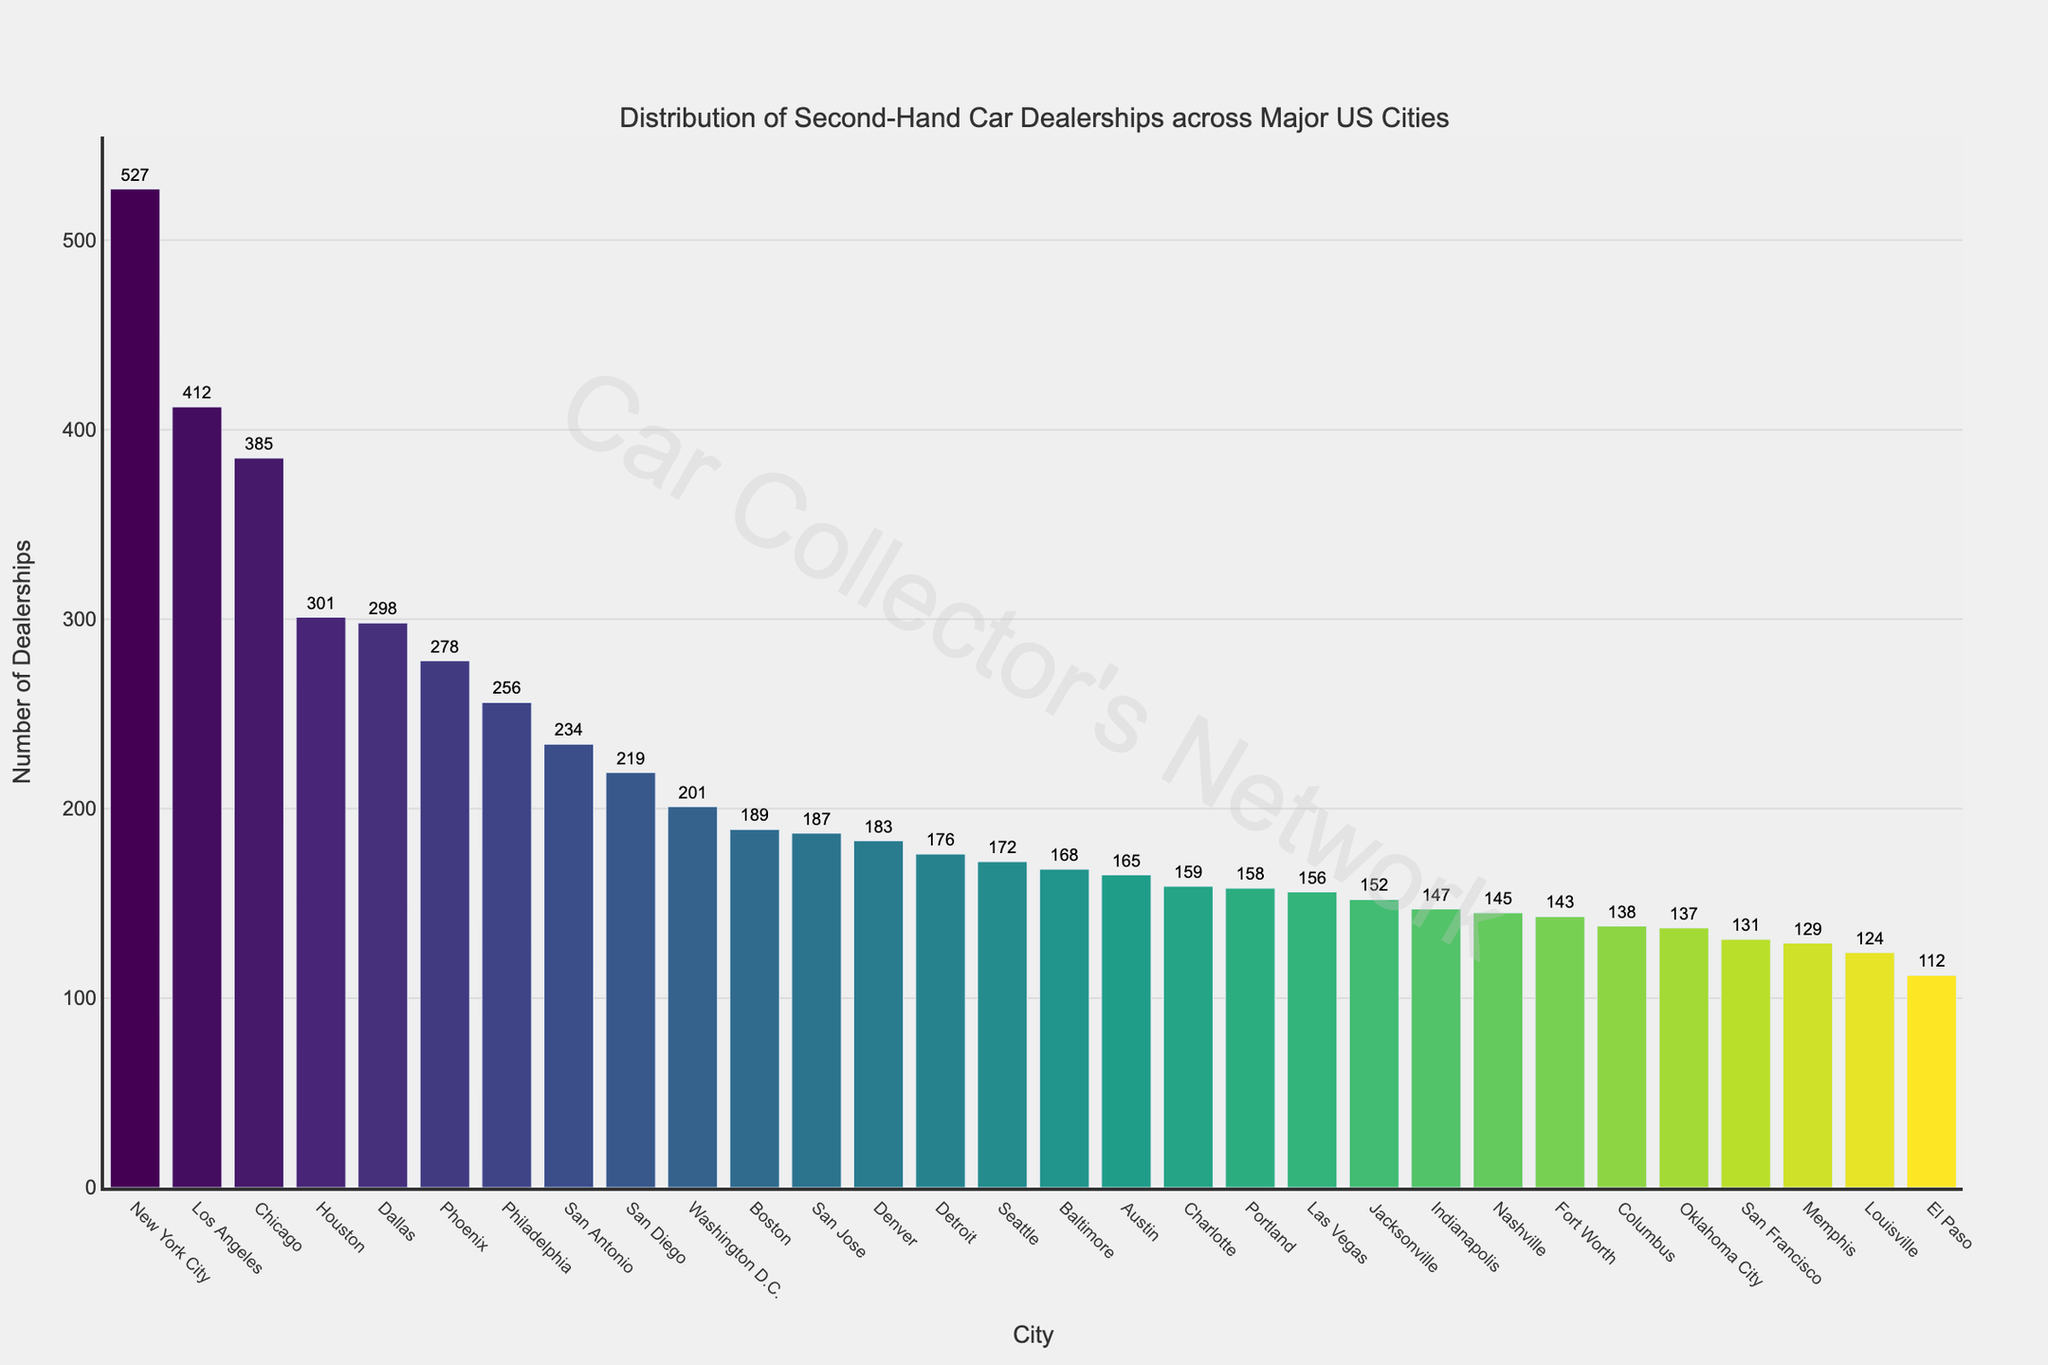Which city has the highest number of second-hand car dealerships? The bar representing New York City is the tallest in the figure, indicating it has the highest number of dealerships. The hovertext confirms New York City has 527 dealerships.
Answer: New York City How does the number of dealerships in Houston compare to those in Dallas? Houston has 301 dealerships and Dallas has 298 dealerships. By comparing the heights of the bars, Houston has a slightly higher number of dealerships than Dallas.
Answer: Houston has more Which cities have fewer than 150 second-hand car dealerships? The cities with bars shorter than the 150 dealerships mark on the y-axis are Jacksonville, Fort Worth, Columbus, San Francisco, El Paso, Nashville, Memphis, Oklahoma City, and Louisville.
Answer: Jacksonville, Fort Worth, Columbus, San Francisco, El Paso, Nashville, Memphis, Oklahoma City, Louisville What is the combined number of dealerships in Los Angeles, Chicago, and Phoenix? The number of dealerships in Los Angeles is 412, Chicago is 385, and Phoenix is 278. Adding them together gives 412 + 385 + 278 = 1075.
Answer: 1075 Which city has the least number of dealerships and how many does it have? El Paso has the shortest bar in the figure, indicating it has the least number of dealerships, which is confirmed by the hovertext showing 112 dealerships.
Answer: El Paso, 112 Are there more dealerships in San Antonio or San Diego, and by how much? San Antonio has 234 dealerships, and San Diego has 219 dealerships. The difference is 234 - 219 = 15.
Answer: San Antonio by 15 What is the average number of dealerships for the cities listed in the figure? Sum the number of dealerships across all cities and divide by the number of cities. The total sum is 7699 dealerships (sum of all data points). There are 30 cities, so the average is 7699 / 30 ≈ 256.63.
Answer: ~257 How does the bar color change as the number of dealerships increases? The color of the bars transitions smoothly from one hue to another using the Viridis color scale, which generally starts from a blue hue and shifts to yellow and green as the number of dealerships increases. The longest bars (New York City, etc.) are in greenish hues, whereas shorter bars are in blueish hues.
Answer: From blue to green/yellow Between which two cities is the biggest change in the number of dealerships observed? Comparing adjacent bars, the biggest drop in the number of dealerships appears between New York City (527) and Los Angeles (412), resulting in a change of 527 - 412 = 115.
Answer: New York City to Los Angeles What percentage of the total dealerships does Boston have? Boston has 189 dealerships. The total number of dealerships is 7699. The percentage is calculated as (189 / 7699) * 100 ≈ 2.45%.
Answer: ~2.45% 